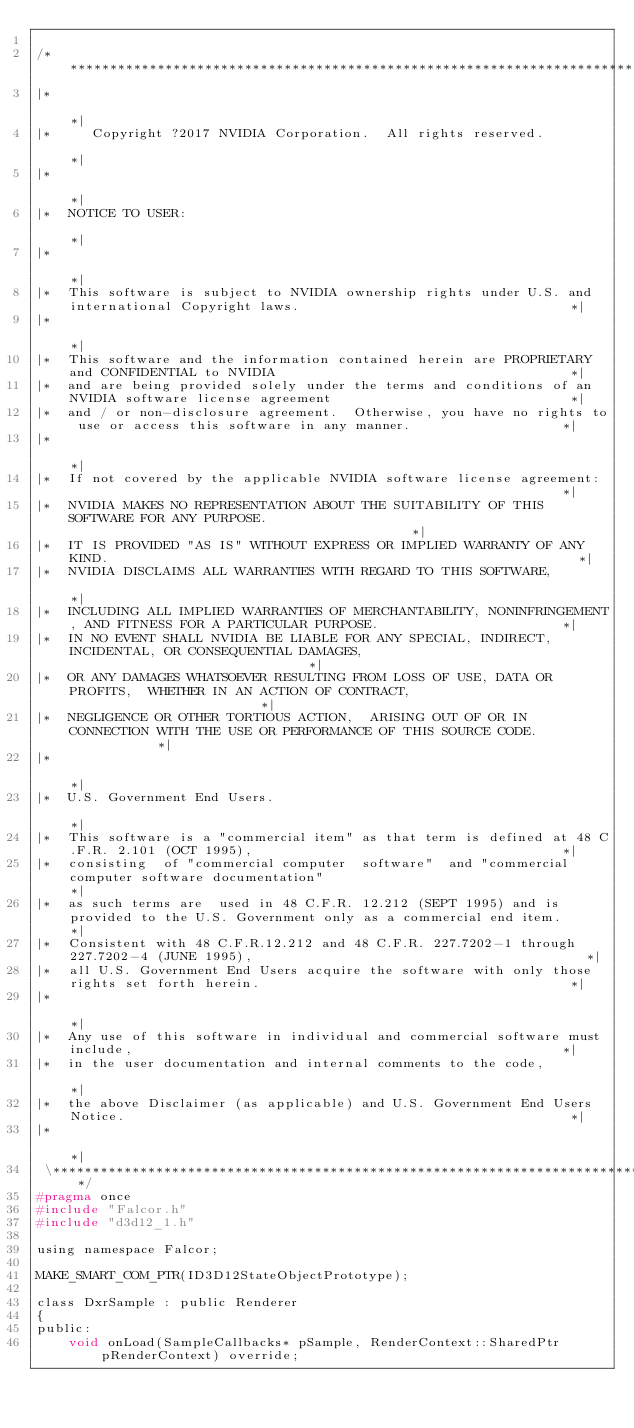<code> <loc_0><loc_0><loc_500><loc_500><_C_>
/************************************************************************************************************************************\
|*                                                                                                                                    *|
|*     Copyright ?2017 NVIDIA Corporation.  All rights reserved.                                                                     *|
|*                                                                                                                                    *|
|*  NOTICE TO USER:                                                                                                                   *|
|*                                                                                                                                    *|
|*  This software is subject to NVIDIA ownership rights under U.S. and international Copyright laws.                                  *|
|*                                                                                                                                    *|
|*  This software and the information contained herein are PROPRIETARY and CONFIDENTIAL to NVIDIA                                     *|
|*  and are being provided solely under the terms and conditions of an NVIDIA software license agreement                              *|
|*  and / or non-disclosure agreement.  Otherwise, you have no rights to use or access this software in any manner.                   *|
|*                                                                                                                                    *|
|*  If not covered by the applicable NVIDIA software license agreement:                                                               *|
|*  NVIDIA MAKES NO REPRESENTATION ABOUT THE SUITABILITY OF THIS SOFTWARE FOR ANY PURPOSE.                                            *|
|*  IT IS PROVIDED "AS IS" WITHOUT EXPRESS OR IMPLIED WARRANTY OF ANY KIND.                                                           *|
|*  NVIDIA DISCLAIMS ALL WARRANTIES WITH REGARD TO THIS SOFTWARE,                                                                     *|
|*  INCLUDING ALL IMPLIED WARRANTIES OF MERCHANTABILITY, NONINFRINGEMENT, AND FITNESS FOR A PARTICULAR PURPOSE.                       *|
|*  IN NO EVENT SHALL NVIDIA BE LIABLE FOR ANY SPECIAL, INDIRECT, INCIDENTAL, OR CONSEQUENTIAL DAMAGES,                               *|
|*  OR ANY DAMAGES WHATSOEVER RESULTING FROM LOSS OF USE, DATA OR PROFITS,  WHETHER IN AN ACTION OF CONTRACT,                         *|
|*  NEGLIGENCE OR OTHER TORTIOUS ACTION,  ARISING OUT OF OR IN CONNECTION WITH THE USE OR PERFORMANCE OF THIS SOURCE CODE.            *|
|*                                                                                                                                    *|
|*  U.S. Government End Users.                                                                                                        *|
|*  This software is a "commercial item" as that term is defined at 48 C.F.R. 2.101 (OCT 1995),                                       *|
|*  consisting  of "commercial computer  software"  and "commercial computer software documentation"                                  *|
|*  as such terms are  used in 48 C.F.R. 12.212 (SEPT 1995) and is provided to the U.S. Government only as a commercial end item.     *|
|*  Consistent with 48 C.F.R.12.212 and 48 C.F.R. 227.7202-1 through 227.7202-4 (JUNE 1995),                                          *|
|*  all U.S. Government End Users acquire the software with only those rights set forth herein.                                       *|
|*                                                                                                                                    *|
|*  Any use of this software in individual and commercial software must include,                                                      *|
|*  in the user documentation and internal comments to the code,                                                                      *|
|*  the above Disclaimer (as applicable) and U.S. Government End Users Notice.                                                        *|
|*                                                                                                                                    *|
 \************************************************************************************************************************************/
#pragma once
#include "Falcor.h"
#include "d3d12_1.h"

using namespace Falcor;

MAKE_SMART_COM_PTR(ID3D12StateObjectPrototype);

class DxrSample : public Renderer
{
public:
    void onLoad(SampleCallbacks* pSample, RenderContext::SharedPtr pRenderContext) override;</code> 